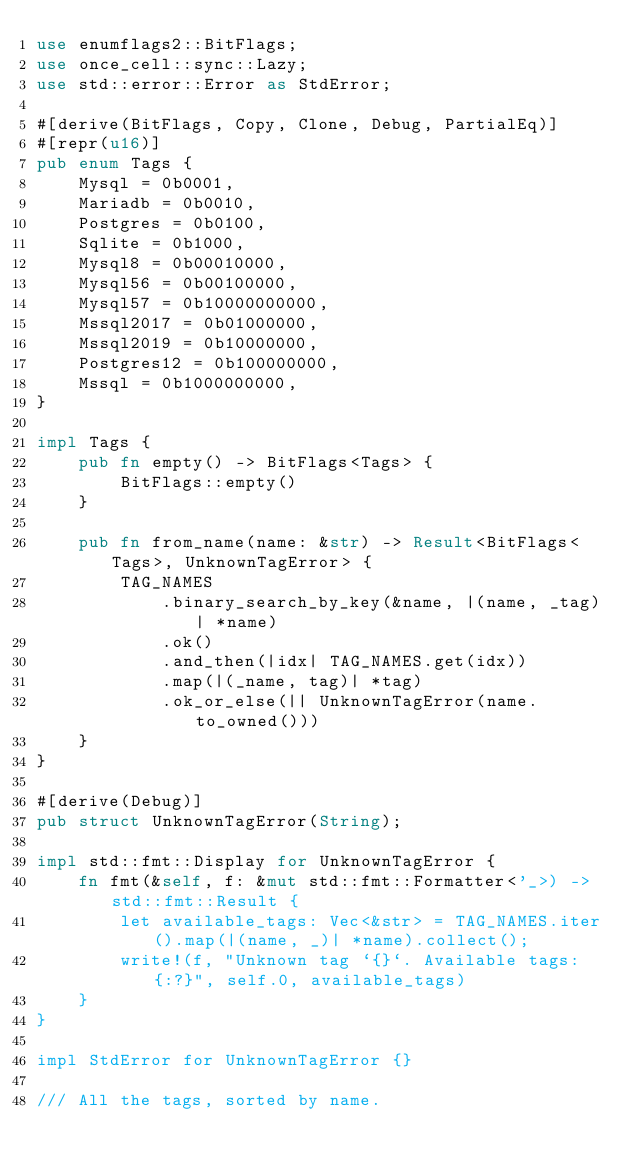<code> <loc_0><loc_0><loc_500><loc_500><_Rust_>use enumflags2::BitFlags;
use once_cell::sync::Lazy;
use std::error::Error as StdError;

#[derive(BitFlags, Copy, Clone, Debug, PartialEq)]
#[repr(u16)]
pub enum Tags {
    Mysql = 0b0001,
    Mariadb = 0b0010,
    Postgres = 0b0100,
    Sqlite = 0b1000,
    Mysql8 = 0b00010000,
    Mysql56 = 0b00100000,
    Mysql57 = 0b10000000000,
    Mssql2017 = 0b01000000,
    Mssql2019 = 0b10000000,
    Postgres12 = 0b100000000,
    Mssql = 0b1000000000,
}

impl Tags {
    pub fn empty() -> BitFlags<Tags> {
        BitFlags::empty()
    }

    pub fn from_name(name: &str) -> Result<BitFlags<Tags>, UnknownTagError> {
        TAG_NAMES
            .binary_search_by_key(&name, |(name, _tag)| *name)
            .ok()
            .and_then(|idx| TAG_NAMES.get(idx))
            .map(|(_name, tag)| *tag)
            .ok_or_else(|| UnknownTagError(name.to_owned()))
    }
}

#[derive(Debug)]
pub struct UnknownTagError(String);

impl std::fmt::Display for UnknownTagError {
    fn fmt(&self, f: &mut std::fmt::Formatter<'_>) -> std::fmt::Result {
        let available_tags: Vec<&str> = TAG_NAMES.iter().map(|(name, _)| *name).collect();
        write!(f, "Unknown tag `{}`. Available tags: {:?}", self.0, available_tags)
    }
}

impl StdError for UnknownTagError {}

/// All the tags, sorted by name.</code> 